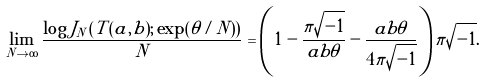Convert formula to latex. <formula><loc_0><loc_0><loc_500><loc_500>\lim _ { N \to \infty } \frac { \log J _ { N } \left ( T ( a , b ) ; \exp ( \theta / N ) \right ) } { N } = \left ( 1 - \frac { \pi \sqrt { - 1 } } { a b \theta } - \frac { a b \theta } { 4 \pi \sqrt { - 1 } } \right ) \pi \sqrt { - 1 } .</formula> 